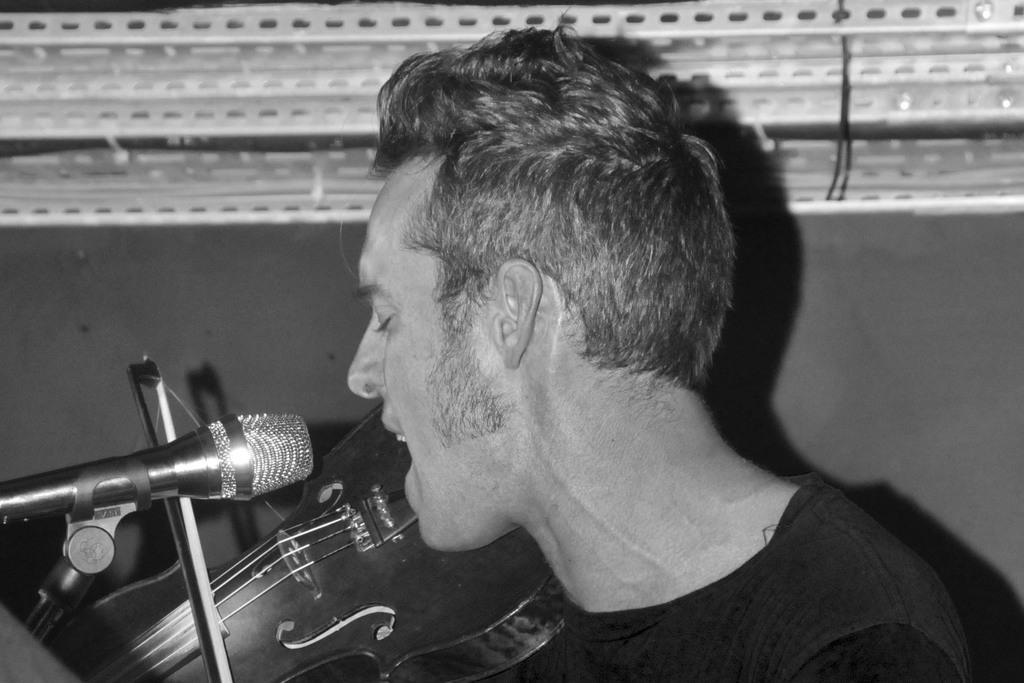What is the main subject of the image? There is a person in the image. What is the person holding in the image? The person is holding a violin. What object is the person standing in front of? The person is standing in front of a microphone. What type of stamp can be seen on the violin in the image? There is no stamp visible on the violin in the image. What color is the lamp behind the person in the image? There is no lamp present in the image. 